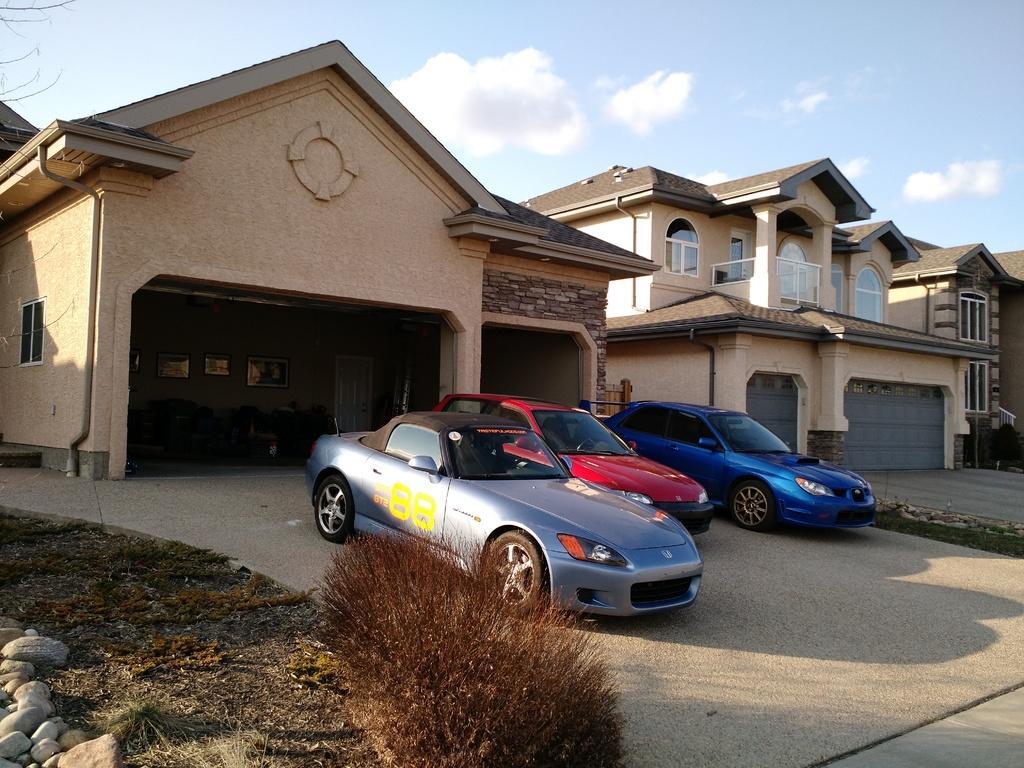Could you give a brief overview of what you see in this image? In the image there are many beautiful houses and different cars were parked in front of those houses, all the houses were painted in cream color and the sunlight is falling on the cars parked in front of the houses, on the left side there are few stones and dry grass and a plant. 